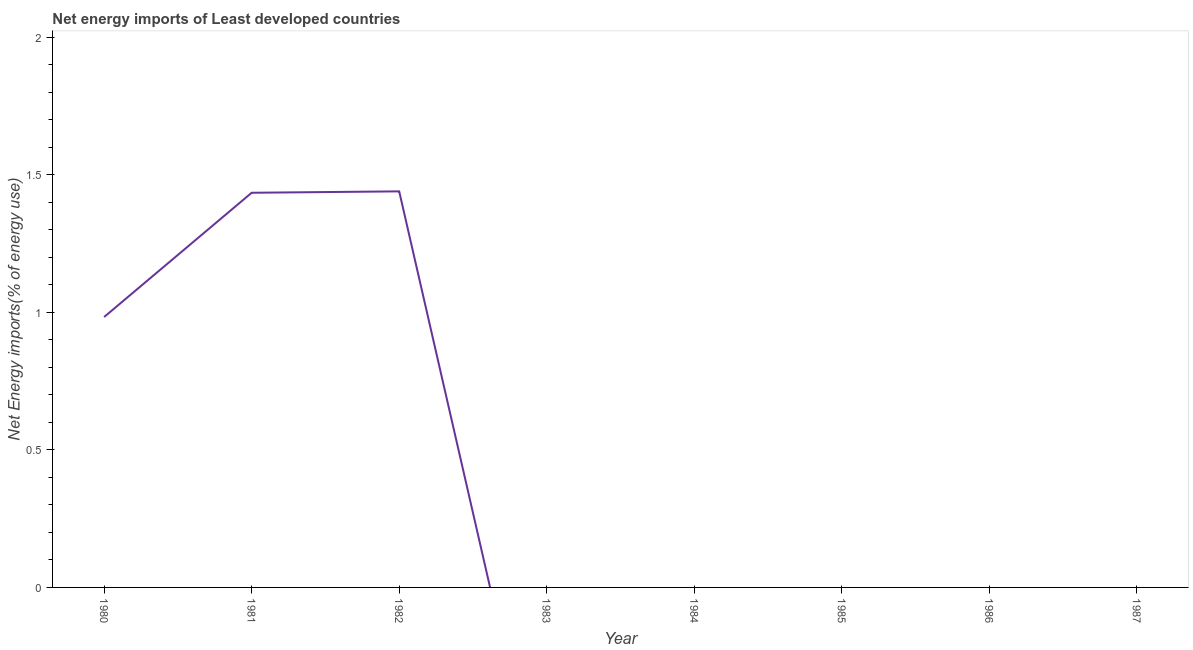Across all years, what is the maximum energy imports?
Offer a very short reply. 1.44. What is the sum of the energy imports?
Keep it short and to the point. 3.86. What is the average energy imports per year?
Provide a short and direct response. 0.48. What is the median energy imports?
Offer a very short reply. 0. What is the ratio of the energy imports in 1980 to that in 1982?
Offer a terse response. 0.68. What is the difference between the highest and the second highest energy imports?
Offer a terse response. 0.01. What is the difference between the highest and the lowest energy imports?
Offer a terse response. 1.44. How many years are there in the graph?
Ensure brevity in your answer.  8. What is the difference between two consecutive major ticks on the Y-axis?
Keep it short and to the point. 0.5. Are the values on the major ticks of Y-axis written in scientific E-notation?
Your response must be concise. No. Does the graph contain grids?
Your answer should be compact. No. What is the title of the graph?
Ensure brevity in your answer.  Net energy imports of Least developed countries. What is the label or title of the Y-axis?
Your answer should be compact. Net Energy imports(% of energy use). What is the Net Energy imports(% of energy use) in 1980?
Ensure brevity in your answer.  0.98. What is the Net Energy imports(% of energy use) of 1981?
Give a very brief answer. 1.44. What is the Net Energy imports(% of energy use) in 1982?
Your answer should be very brief. 1.44. What is the Net Energy imports(% of energy use) of 1983?
Provide a succinct answer. 0. What is the Net Energy imports(% of energy use) of 1984?
Give a very brief answer. 0. What is the Net Energy imports(% of energy use) of 1985?
Your answer should be compact. 0. What is the difference between the Net Energy imports(% of energy use) in 1980 and 1981?
Your response must be concise. -0.45. What is the difference between the Net Energy imports(% of energy use) in 1980 and 1982?
Provide a short and direct response. -0.46. What is the difference between the Net Energy imports(% of energy use) in 1981 and 1982?
Ensure brevity in your answer.  -0.01. What is the ratio of the Net Energy imports(% of energy use) in 1980 to that in 1981?
Provide a succinct answer. 0.69. What is the ratio of the Net Energy imports(% of energy use) in 1980 to that in 1982?
Give a very brief answer. 0.68. 